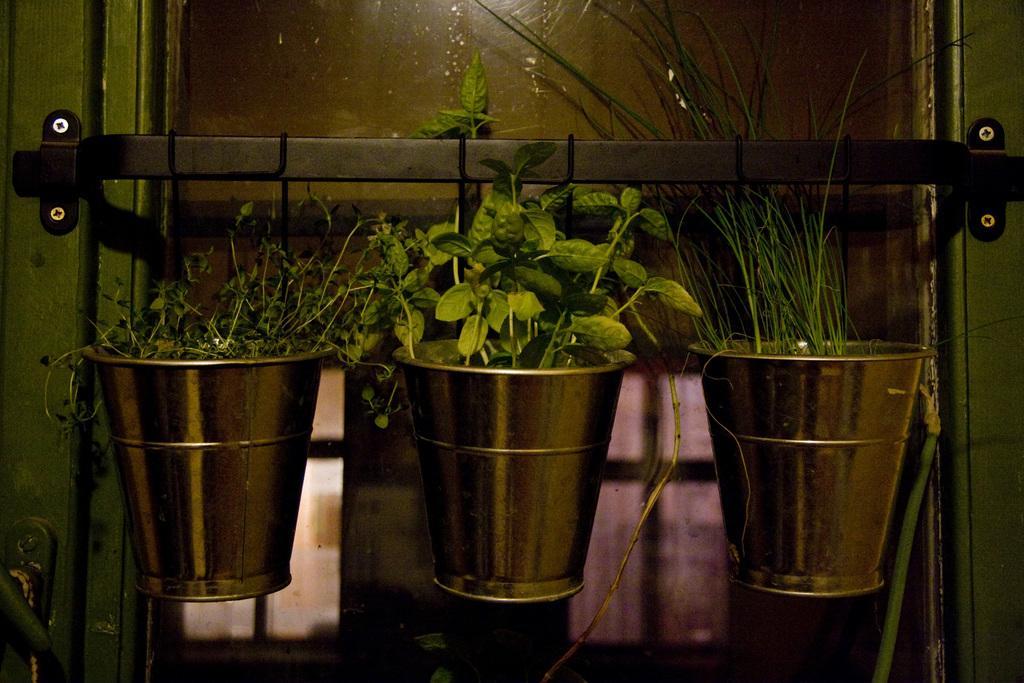Describe this image in one or two sentences. In the center of the picture there are buckets, plants and grass. In the center of the picture there is a window and an iron bar. 